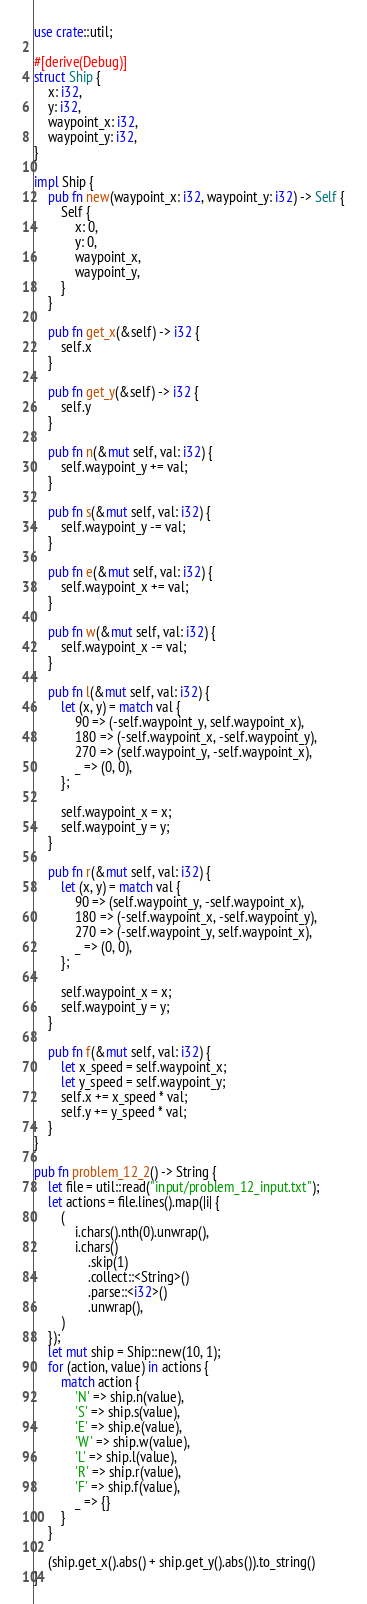<code> <loc_0><loc_0><loc_500><loc_500><_Rust_>use crate::util;

#[derive(Debug)]
struct Ship {
    x: i32,
    y: i32,
    waypoint_x: i32,
    waypoint_y: i32,
}

impl Ship {
    pub fn new(waypoint_x: i32, waypoint_y: i32) -> Self {
        Self {
            x: 0,
            y: 0,
            waypoint_x,
            waypoint_y,
        }
    }

    pub fn get_x(&self) -> i32 {
        self.x
    }

    pub fn get_y(&self) -> i32 {
        self.y
    }

    pub fn n(&mut self, val: i32) {
        self.waypoint_y += val;
    }

    pub fn s(&mut self, val: i32) {
        self.waypoint_y -= val;
    }

    pub fn e(&mut self, val: i32) {
        self.waypoint_x += val;
    }

    pub fn w(&mut self, val: i32) {
        self.waypoint_x -= val;
    }

    pub fn l(&mut self, val: i32) {
        let (x, y) = match val {
            90 => (-self.waypoint_y, self.waypoint_x),
            180 => (-self.waypoint_x, -self.waypoint_y),
            270 => (self.waypoint_y, -self.waypoint_x),
            _ => (0, 0),
        };

        self.waypoint_x = x;
        self.waypoint_y = y;
    }

    pub fn r(&mut self, val: i32) {
        let (x, y) = match val {
            90 => (self.waypoint_y, -self.waypoint_x),
            180 => (-self.waypoint_x, -self.waypoint_y),
            270 => (-self.waypoint_y, self.waypoint_x),
            _ => (0, 0),
        };

        self.waypoint_x = x;
        self.waypoint_y = y;
    }

    pub fn f(&mut self, val: i32) {
        let x_speed = self.waypoint_x;
        let y_speed = self.waypoint_y;
        self.x += x_speed * val;
        self.y += y_speed * val;
    }
}

pub fn problem_12_2() -> String {
    let file = util::read("input/problem_12_input.txt");
    let actions = file.lines().map(|i| {
        (
            i.chars().nth(0).unwrap(),
            i.chars()
                .skip(1)
                .collect::<String>()
                .parse::<i32>()
                .unwrap(),
        )
    });
    let mut ship = Ship::new(10, 1);
    for (action, value) in actions {
        match action {
            'N' => ship.n(value),
            'S' => ship.s(value),
            'E' => ship.e(value),
            'W' => ship.w(value),
            'L' => ship.l(value),
            'R' => ship.r(value),
            'F' => ship.f(value),
            _ => {}
        }
    }

    (ship.get_x().abs() + ship.get_y().abs()).to_string()
}
</code> 